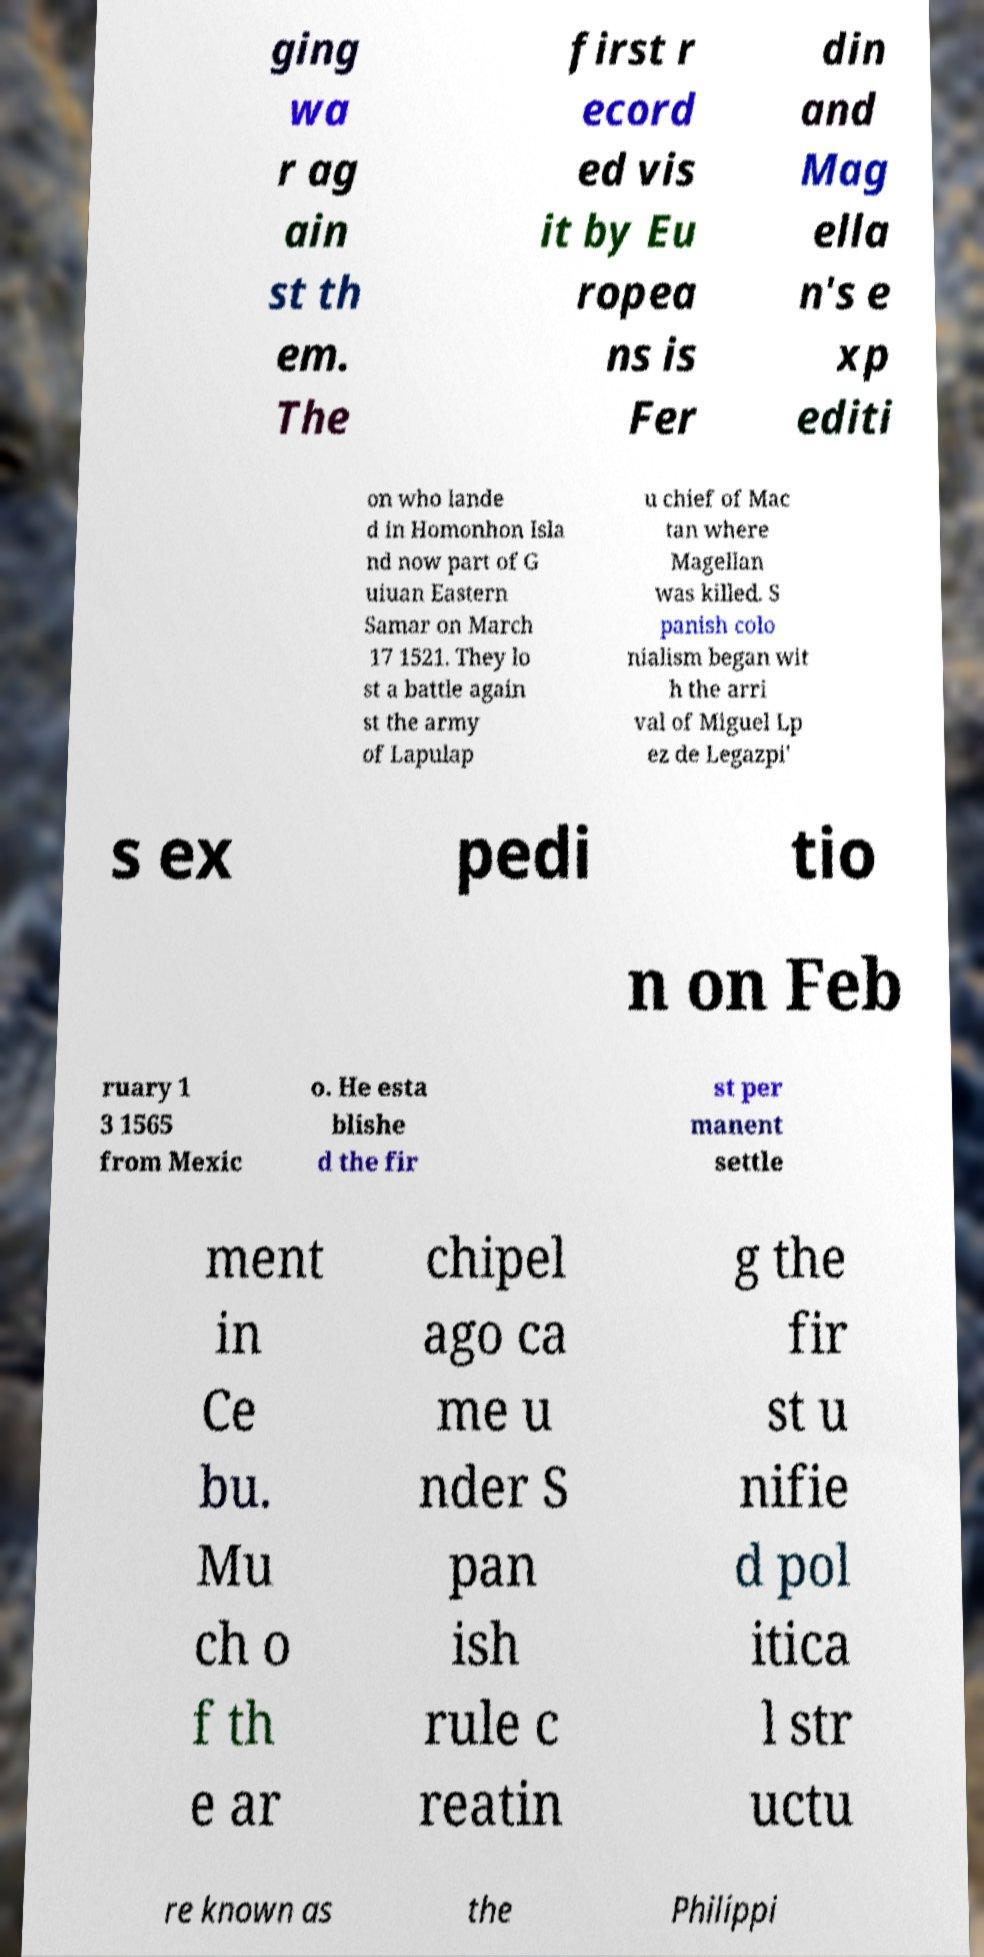There's text embedded in this image that I need extracted. Can you transcribe it verbatim? ging wa r ag ain st th em. The first r ecord ed vis it by Eu ropea ns is Fer din and Mag ella n's e xp editi on who lande d in Homonhon Isla nd now part of G uiuan Eastern Samar on March 17 1521. They lo st a battle again st the army of Lapulap u chief of Mac tan where Magellan was killed. S panish colo nialism began wit h the arri val of Miguel Lp ez de Legazpi' s ex pedi tio n on Feb ruary 1 3 1565 from Mexic o. He esta blishe d the fir st per manent settle ment in Ce bu. Mu ch o f th e ar chipel ago ca me u nder S pan ish rule c reatin g the fir st u nifie d pol itica l str uctu re known as the Philippi 